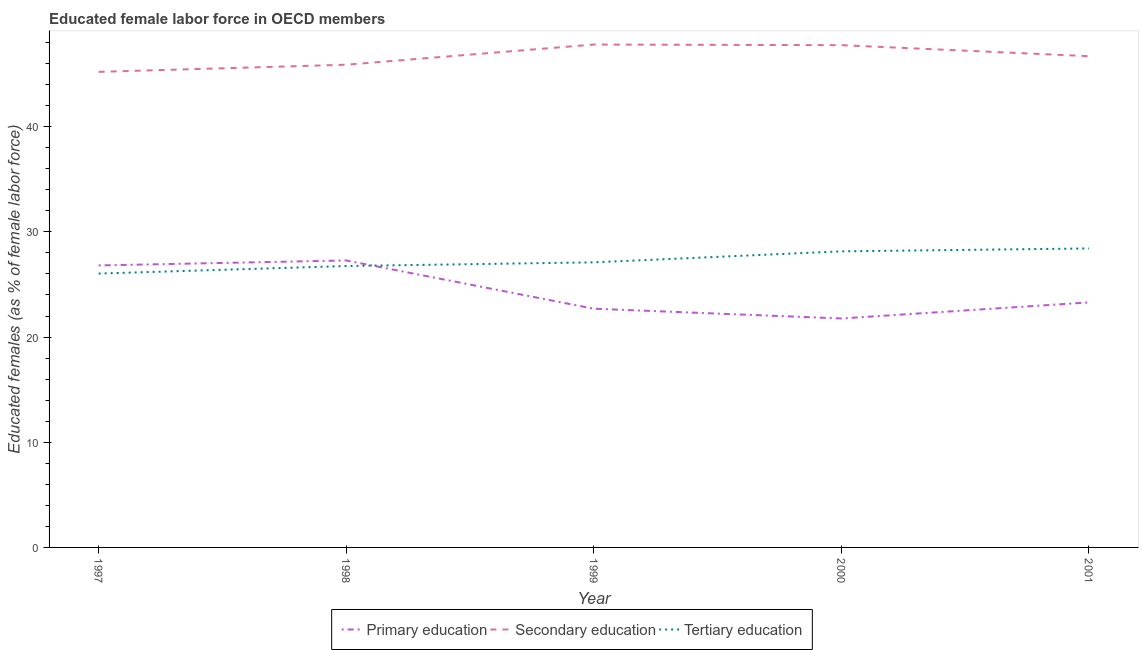How many different coloured lines are there?
Offer a very short reply. 3. Is the number of lines equal to the number of legend labels?
Your response must be concise. Yes. What is the percentage of female labor force who received secondary education in 1997?
Ensure brevity in your answer.  45.21. Across all years, what is the maximum percentage of female labor force who received primary education?
Offer a terse response. 27.28. Across all years, what is the minimum percentage of female labor force who received tertiary education?
Your answer should be very brief. 26.03. In which year was the percentage of female labor force who received primary education minimum?
Offer a very short reply. 2000. What is the total percentage of female labor force who received primary education in the graph?
Make the answer very short. 121.84. What is the difference between the percentage of female labor force who received secondary education in 1998 and that in 2001?
Offer a very short reply. -0.81. What is the difference between the percentage of female labor force who received primary education in 2001 and the percentage of female labor force who received tertiary education in 1998?
Offer a terse response. -3.46. What is the average percentage of female labor force who received secondary education per year?
Ensure brevity in your answer.  46.67. In the year 1998, what is the difference between the percentage of female labor force who received primary education and percentage of female labor force who received secondary education?
Provide a succinct answer. -18.61. What is the ratio of the percentage of female labor force who received tertiary education in 1997 to that in 1999?
Offer a terse response. 0.96. Is the percentage of female labor force who received primary education in 1997 less than that in 1999?
Your response must be concise. No. What is the difference between the highest and the second highest percentage of female labor force who received tertiary education?
Your answer should be compact. 0.28. What is the difference between the highest and the lowest percentage of female labor force who received primary education?
Offer a very short reply. 5.52. In how many years, is the percentage of female labor force who received tertiary education greater than the average percentage of female labor force who received tertiary education taken over all years?
Ensure brevity in your answer.  2. Is it the case that in every year, the sum of the percentage of female labor force who received primary education and percentage of female labor force who received secondary education is greater than the percentage of female labor force who received tertiary education?
Your answer should be compact. Yes. Is the percentage of female labor force who received secondary education strictly less than the percentage of female labor force who received tertiary education over the years?
Your answer should be very brief. No. Are the values on the major ticks of Y-axis written in scientific E-notation?
Your answer should be compact. No. Does the graph contain any zero values?
Your answer should be very brief. No. How many legend labels are there?
Provide a succinct answer. 3. What is the title of the graph?
Provide a short and direct response. Educated female labor force in OECD members. Does "Argument" appear as one of the legend labels in the graph?
Offer a very short reply. No. What is the label or title of the X-axis?
Your answer should be very brief. Year. What is the label or title of the Y-axis?
Make the answer very short. Educated females (as % of female labor force). What is the Educated females (as % of female labor force) of Primary education in 1997?
Give a very brief answer. 26.81. What is the Educated females (as % of female labor force) of Secondary education in 1997?
Keep it short and to the point. 45.21. What is the Educated females (as % of female labor force) of Tertiary education in 1997?
Your response must be concise. 26.03. What is the Educated females (as % of female labor force) of Primary education in 1998?
Keep it short and to the point. 27.28. What is the Educated females (as % of female labor force) in Secondary education in 1998?
Give a very brief answer. 45.89. What is the Educated females (as % of female labor force) of Tertiary education in 1998?
Keep it short and to the point. 26.75. What is the Educated females (as % of female labor force) in Primary education in 1999?
Provide a succinct answer. 22.7. What is the Educated females (as % of female labor force) in Secondary education in 1999?
Ensure brevity in your answer.  47.81. What is the Educated females (as % of female labor force) in Tertiary education in 1999?
Ensure brevity in your answer.  27.1. What is the Educated females (as % of female labor force) of Primary education in 2000?
Make the answer very short. 21.77. What is the Educated females (as % of female labor force) of Secondary education in 2000?
Offer a terse response. 47.75. What is the Educated females (as % of female labor force) of Tertiary education in 2000?
Give a very brief answer. 28.15. What is the Educated females (as % of female labor force) in Primary education in 2001?
Your answer should be compact. 23.29. What is the Educated females (as % of female labor force) of Secondary education in 2001?
Give a very brief answer. 46.7. What is the Educated females (as % of female labor force) of Tertiary education in 2001?
Keep it short and to the point. 28.42. Across all years, what is the maximum Educated females (as % of female labor force) in Primary education?
Your response must be concise. 27.28. Across all years, what is the maximum Educated females (as % of female labor force) in Secondary education?
Keep it short and to the point. 47.81. Across all years, what is the maximum Educated females (as % of female labor force) of Tertiary education?
Ensure brevity in your answer.  28.42. Across all years, what is the minimum Educated females (as % of female labor force) in Primary education?
Provide a succinct answer. 21.77. Across all years, what is the minimum Educated females (as % of female labor force) of Secondary education?
Your answer should be very brief. 45.21. Across all years, what is the minimum Educated females (as % of female labor force) of Tertiary education?
Provide a short and direct response. 26.03. What is the total Educated females (as % of female labor force) in Primary education in the graph?
Your answer should be very brief. 121.84. What is the total Educated females (as % of female labor force) in Secondary education in the graph?
Keep it short and to the point. 233.36. What is the total Educated females (as % of female labor force) in Tertiary education in the graph?
Provide a succinct answer. 136.46. What is the difference between the Educated females (as % of female labor force) of Primary education in 1997 and that in 1998?
Your answer should be very brief. -0.47. What is the difference between the Educated females (as % of female labor force) in Secondary education in 1997 and that in 1998?
Give a very brief answer. -0.68. What is the difference between the Educated females (as % of female labor force) in Tertiary education in 1997 and that in 1998?
Make the answer very short. -0.72. What is the difference between the Educated females (as % of female labor force) in Primary education in 1997 and that in 1999?
Make the answer very short. 4.11. What is the difference between the Educated females (as % of female labor force) of Secondary education in 1997 and that in 1999?
Provide a succinct answer. -2.6. What is the difference between the Educated females (as % of female labor force) of Tertiary education in 1997 and that in 1999?
Your answer should be very brief. -1.07. What is the difference between the Educated females (as % of female labor force) of Primary education in 1997 and that in 2000?
Your answer should be compact. 5.04. What is the difference between the Educated females (as % of female labor force) in Secondary education in 1997 and that in 2000?
Your response must be concise. -2.54. What is the difference between the Educated females (as % of female labor force) of Tertiary education in 1997 and that in 2000?
Provide a short and direct response. -2.11. What is the difference between the Educated females (as % of female labor force) in Primary education in 1997 and that in 2001?
Keep it short and to the point. 3.52. What is the difference between the Educated females (as % of female labor force) of Secondary education in 1997 and that in 2001?
Provide a succinct answer. -1.49. What is the difference between the Educated females (as % of female labor force) of Tertiary education in 1997 and that in 2001?
Ensure brevity in your answer.  -2.39. What is the difference between the Educated females (as % of female labor force) of Primary education in 1998 and that in 1999?
Offer a very short reply. 4.59. What is the difference between the Educated females (as % of female labor force) in Secondary education in 1998 and that in 1999?
Give a very brief answer. -1.92. What is the difference between the Educated females (as % of female labor force) of Tertiary education in 1998 and that in 1999?
Keep it short and to the point. -0.35. What is the difference between the Educated females (as % of female labor force) in Primary education in 1998 and that in 2000?
Your answer should be very brief. 5.52. What is the difference between the Educated females (as % of female labor force) of Secondary education in 1998 and that in 2000?
Provide a short and direct response. -1.86. What is the difference between the Educated females (as % of female labor force) in Tertiary education in 1998 and that in 2000?
Offer a very short reply. -1.4. What is the difference between the Educated females (as % of female labor force) of Primary education in 1998 and that in 2001?
Offer a very short reply. 3.99. What is the difference between the Educated females (as % of female labor force) in Secondary education in 1998 and that in 2001?
Keep it short and to the point. -0.81. What is the difference between the Educated females (as % of female labor force) in Tertiary education in 1998 and that in 2001?
Offer a very short reply. -1.67. What is the difference between the Educated females (as % of female labor force) of Primary education in 1999 and that in 2000?
Offer a very short reply. 0.93. What is the difference between the Educated females (as % of female labor force) of Secondary education in 1999 and that in 2000?
Provide a short and direct response. 0.06. What is the difference between the Educated females (as % of female labor force) in Tertiary education in 1999 and that in 2000?
Offer a very short reply. -1.05. What is the difference between the Educated females (as % of female labor force) in Primary education in 1999 and that in 2001?
Ensure brevity in your answer.  -0.6. What is the difference between the Educated females (as % of female labor force) of Secondary education in 1999 and that in 2001?
Make the answer very short. 1.11. What is the difference between the Educated females (as % of female labor force) of Tertiary education in 1999 and that in 2001?
Your answer should be compact. -1.32. What is the difference between the Educated females (as % of female labor force) of Primary education in 2000 and that in 2001?
Your answer should be very brief. -1.53. What is the difference between the Educated females (as % of female labor force) in Secondary education in 2000 and that in 2001?
Keep it short and to the point. 1.05. What is the difference between the Educated females (as % of female labor force) of Tertiary education in 2000 and that in 2001?
Your answer should be compact. -0.28. What is the difference between the Educated females (as % of female labor force) of Primary education in 1997 and the Educated females (as % of female labor force) of Secondary education in 1998?
Your response must be concise. -19.08. What is the difference between the Educated females (as % of female labor force) of Primary education in 1997 and the Educated females (as % of female labor force) of Tertiary education in 1998?
Your response must be concise. 0.06. What is the difference between the Educated females (as % of female labor force) of Secondary education in 1997 and the Educated females (as % of female labor force) of Tertiary education in 1998?
Ensure brevity in your answer.  18.46. What is the difference between the Educated females (as % of female labor force) in Primary education in 1997 and the Educated females (as % of female labor force) in Secondary education in 1999?
Ensure brevity in your answer.  -21. What is the difference between the Educated females (as % of female labor force) of Primary education in 1997 and the Educated females (as % of female labor force) of Tertiary education in 1999?
Offer a terse response. -0.29. What is the difference between the Educated females (as % of female labor force) of Secondary education in 1997 and the Educated females (as % of female labor force) of Tertiary education in 1999?
Your answer should be very brief. 18.11. What is the difference between the Educated females (as % of female labor force) in Primary education in 1997 and the Educated females (as % of female labor force) in Secondary education in 2000?
Make the answer very short. -20.94. What is the difference between the Educated females (as % of female labor force) of Primary education in 1997 and the Educated females (as % of female labor force) of Tertiary education in 2000?
Give a very brief answer. -1.34. What is the difference between the Educated females (as % of female labor force) of Secondary education in 1997 and the Educated females (as % of female labor force) of Tertiary education in 2000?
Your answer should be very brief. 17.06. What is the difference between the Educated females (as % of female labor force) in Primary education in 1997 and the Educated females (as % of female labor force) in Secondary education in 2001?
Offer a terse response. -19.89. What is the difference between the Educated females (as % of female labor force) of Primary education in 1997 and the Educated females (as % of female labor force) of Tertiary education in 2001?
Provide a short and direct response. -1.62. What is the difference between the Educated females (as % of female labor force) in Secondary education in 1997 and the Educated females (as % of female labor force) in Tertiary education in 2001?
Offer a terse response. 16.79. What is the difference between the Educated females (as % of female labor force) of Primary education in 1998 and the Educated females (as % of female labor force) of Secondary education in 1999?
Give a very brief answer. -20.53. What is the difference between the Educated females (as % of female labor force) of Primary education in 1998 and the Educated females (as % of female labor force) of Tertiary education in 1999?
Your answer should be compact. 0.18. What is the difference between the Educated females (as % of female labor force) of Secondary education in 1998 and the Educated females (as % of female labor force) of Tertiary education in 1999?
Ensure brevity in your answer.  18.79. What is the difference between the Educated females (as % of female labor force) in Primary education in 1998 and the Educated females (as % of female labor force) in Secondary education in 2000?
Your answer should be compact. -20.47. What is the difference between the Educated females (as % of female labor force) in Primary education in 1998 and the Educated females (as % of female labor force) in Tertiary education in 2000?
Give a very brief answer. -0.87. What is the difference between the Educated females (as % of female labor force) of Secondary education in 1998 and the Educated females (as % of female labor force) of Tertiary education in 2000?
Your answer should be compact. 17.74. What is the difference between the Educated females (as % of female labor force) of Primary education in 1998 and the Educated females (as % of female labor force) of Secondary education in 2001?
Your answer should be compact. -19.42. What is the difference between the Educated females (as % of female labor force) of Primary education in 1998 and the Educated females (as % of female labor force) of Tertiary education in 2001?
Your answer should be very brief. -1.14. What is the difference between the Educated females (as % of female labor force) of Secondary education in 1998 and the Educated females (as % of female labor force) of Tertiary education in 2001?
Make the answer very short. 17.47. What is the difference between the Educated females (as % of female labor force) of Primary education in 1999 and the Educated females (as % of female labor force) of Secondary education in 2000?
Your answer should be compact. -25.05. What is the difference between the Educated females (as % of female labor force) of Primary education in 1999 and the Educated females (as % of female labor force) of Tertiary education in 2000?
Offer a terse response. -5.45. What is the difference between the Educated females (as % of female labor force) in Secondary education in 1999 and the Educated females (as % of female labor force) in Tertiary education in 2000?
Your response must be concise. 19.66. What is the difference between the Educated females (as % of female labor force) of Primary education in 1999 and the Educated females (as % of female labor force) of Secondary education in 2001?
Provide a short and direct response. -24.01. What is the difference between the Educated females (as % of female labor force) of Primary education in 1999 and the Educated females (as % of female labor force) of Tertiary education in 2001?
Keep it short and to the point. -5.73. What is the difference between the Educated females (as % of female labor force) in Secondary education in 1999 and the Educated females (as % of female labor force) in Tertiary education in 2001?
Your response must be concise. 19.39. What is the difference between the Educated females (as % of female labor force) in Primary education in 2000 and the Educated females (as % of female labor force) in Secondary education in 2001?
Keep it short and to the point. -24.94. What is the difference between the Educated females (as % of female labor force) of Primary education in 2000 and the Educated females (as % of female labor force) of Tertiary education in 2001?
Your answer should be very brief. -6.66. What is the difference between the Educated females (as % of female labor force) in Secondary education in 2000 and the Educated females (as % of female labor force) in Tertiary education in 2001?
Your answer should be compact. 19.32. What is the average Educated females (as % of female labor force) in Primary education per year?
Offer a terse response. 24.37. What is the average Educated females (as % of female labor force) of Secondary education per year?
Make the answer very short. 46.67. What is the average Educated females (as % of female labor force) of Tertiary education per year?
Keep it short and to the point. 27.29. In the year 1997, what is the difference between the Educated females (as % of female labor force) of Primary education and Educated females (as % of female labor force) of Secondary education?
Ensure brevity in your answer.  -18.4. In the year 1997, what is the difference between the Educated females (as % of female labor force) of Primary education and Educated females (as % of female labor force) of Tertiary education?
Your response must be concise. 0.77. In the year 1997, what is the difference between the Educated females (as % of female labor force) of Secondary education and Educated females (as % of female labor force) of Tertiary education?
Make the answer very short. 19.18. In the year 1998, what is the difference between the Educated females (as % of female labor force) of Primary education and Educated females (as % of female labor force) of Secondary education?
Provide a succinct answer. -18.61. In the year 1998, what is the difference between the Educated females (as % of female labor force) in Primary education and Educated females (as % of female labor force) in Tertiary education?
Your response must be concise. 0.53. In the year 1998, what is the difference between the Educated females (as % of female labor force) of Secondary education and Educated females (as % of female labor force) of Tertiary education?
Your response must be concise. 19.14. In the year 1999, what is the difference between the Educated females (as % of female labor force) in Primary education and Educated females (as % of female labor force) in Secondary education?
Keep it short and to the point. -25.11. In the year 1999, what is the difference between the Educated females (as % of female labor force) of Primary education and Educated females (as % of female labor force) of Tertiary education?
Your answer should be very brief. -4.41. In the year 1999, what is the difference between the Educated females (as % of female labor force) of Secondary education and Educated females (as % of female labor force) of Tertiary education?
Make the answer very short. 20.71. In the year 2000, what is the difference between the Educated females (as % of female labor force) in Primary education and Educated females (as % of female labor force) in Secondary education?
Your answer should be very brief. -25.98. In the year 2000, what is the difference between the Educated females (as % of female labor force) in Primary education and Educated females (as % of female labor force) in Tertiary education?
Offer a terse response. -6.38. In the year 2000, what is the difference between the Educated females (as % of female labor force) of Secondary education and Educated females (as % of female labor force) of Tertiary education?
Your answer should be compact. 19.6. In the year 2001, what is the difference between the Educated females (as % of female labor force) in Primary education and Educated females (as % of female labor force) in Secondary education?
Your response must be concise. -23.41. In the year 2001, what is the difference between the Educated females (as % of female labor force) in Primary education and Educated females (as % of female labor force) in Tertiary education?
Offer a very short reply. -5.13. In the year 2001, what is the difference between the Educated females (as % of female labor force) of Secondary education and Educated females (as % of female labor force) of Tertiary education?
Provide a succinct answer. 18.28. What is the ratio of the Educated females (as % of female labor force) in Primary education in 1997 to that in 1998?
Make the answer very short. 0.98. What is the ratio of the Educated females (as % of female labor force) of Secondary education in 1997 to that in 1998?
Make the answer very short. 0.99. What is the ratio of the Educated females (as % of female labor force) in Tertiary education in 1997 to that in 1998?
Make the answer very short. 0.97. What is the ratio of the Educated females (as % of female labor force) of Primary education in 1997 to that in 1999?
Your response must be concise. 1.18. What is the ratio of the Educated females (as % of female labor force) in Secondary education in 1997 to that in 1999?
Offer a terse response. 0.95. What is the ratio of the Educated females (as % of female labor force) in Tertiary education in 1997 to that in 1999?
Offer a very short reply. 0.96. What is the ratio of the Educated females (as % of female labor force) in Primary education in 1997 to that in 2000?
Provide a short and direct response. 1.23. What is the ratio of the Educated females (as % of female labor force) in Secondary education in 1997 to that in 2000?
Make the answer very short. 0.95. What is the ratio of the Educated females (as % of female labor force) in Tertiary education in 1997 to that in 2000?
Your answer should be very brief. 0.92. What is the ratio of the Educated females (as % of female labor force) of Primary education in 1997 to that in 2001?
Your answer should be compact. 1.15. What is the ratio of the Educated females (as % of female labor force) of Secondary education in 1997 to that in 2001?
Offer a terse response. 0.97. What is the ratio of the Educated females (as % of female labor force) of Tertiary education in 1997 to that in 2001?
Your response must be concise. 0.92. What is the ratio of the Educated females (as % of female labor force) in Primary education in 1998 to that in 1999?
Your response must be concise. 1.2. What is the ratio of the Educated females (as % of female labor force) in Secondary education in 1998 to that in 1999?
Ensure brevity in your answer.  0.96. What is the ratio of the Educated females (as % of female labor force) of Tertiary education in 1998 to that in 1999?
Your answer should be compact. 0.99. What is the ratio of the Educated females (as % of female labor force) in Primary education in 1998 to that in 2000?
Give a very brief answer. 1.25. What is the ratio of the Educated females (as % of female labor force) of Secondary education in 1998 to that in 2000?
Your answer should be compact. 0.96. What is the ratio of the Educated females (as % of female labor force) of Tertiary education in 1998 to that in 2000?
Offer a terse response. 0.95. What is the ratio of the Educated females (as % of female labor force) of Primary education in 1998 to that in 2001?
Your response must be concise. 1.17. What is the ratio of the Educated females (as % of female labor force) of Secondary education in 1998 to that in 2001?
Ensure brevity in your answer.  0.98. What is the ratio of the Educated females (as % of female labor force) in Primary education in 1999 to that in 2000?
Your answer should be compact. 1.04. What is the ratio of the Educated females (as % of female labor force) in Tertiary education in 1999 to that in 2000?
Offer a very short reply. 0.96. What is the ratio of the Educated females (as % of female labor force) of Primary education in 1999 to that in 2001?
Give a very brief answer. 0.97. What is the ratio of the Educated females (as % of female labor force) of Secondary education in 1999 to that in 2001?
Offer a terse response. 1.02. What is the ratio of the Educated females (as % of female labor force) of Tertiary education in 1999 to that in 2001?
Make the answer very short. 0.95. What is the ratio of the Educated females (as % of female labor force) of Primary education in 2000 to that in 2001?
Ensure brevity in your answer.  0.93. What is the ratio of the Educated females (as % of female labor force) of Secondary education in 2000 to that in 2001?
Make the answer very short. 1.02. What is the ratio of the Educated females (as % of female labor force) of Tertiary education in 2000 to that in 2001?
Your answer should be very brief. 0.99. What is the difference between the highest and the second highest Educated females (as % of female labor force) in Primary education?
Make the answer very short. 0.47. What is the difference between the highest and the second highest Educated females (as % of female labor force) of Secondary education?
Give a very brief answer. 0.06. What is the difference between the highest and the second highest Educated females (as % of female labor force) of Tertiary education?
Ensure brevity in your answer.  0.28. What is the difference between the highest and the lowest Educated females (as % of female labor force) in Primary education?
Your answer should be compact. 5.52. What is the difference between the highest and the lowest Educated females (as % of female labor force) of Secondary education?
Offer a terse response. 2.6. What is the difference between the highest and the lowest Educated females (as % of female labor force) in Tertiary education?
Your answer should be very brief. 2.39. 